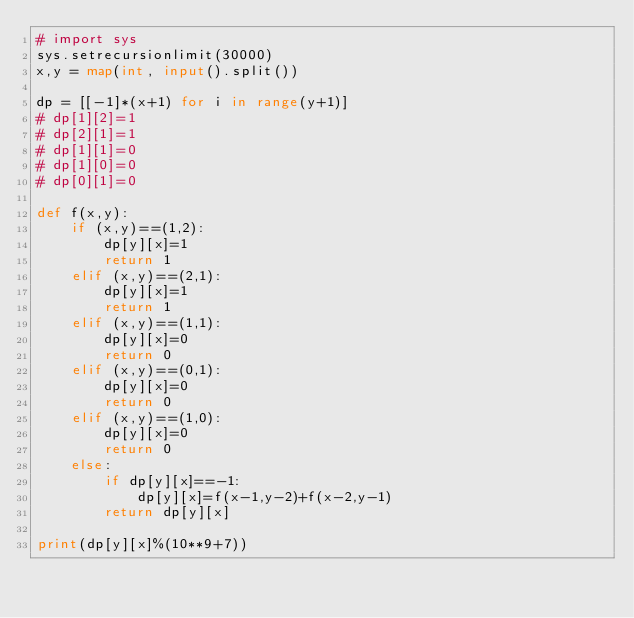Convert code to text. <code><loc_0><loc_0><loc_500><loc_500><_Python_># import sys
sys.setrecursionlimit(30000)
x,y = map(int, input().split())

dp = [[-1]*(x+1) for i in range(y+1)]
# dp[1][2]=1
# dp[2][1]=1
# dp[1][1]=0
# dp[1][0]=0
# dp[0][1]=0

def f(x,y):
    if (x,y)==(1,2):
        dp[y][x]=1
        return 1
    elif (x,y)==(2,1):
        dp[y][x]=1
        return 1
    elif (x,y)==(1,1):
        dp[y][x]=0
        return 0
    elif (x,y)==(0,1):
        dp[y][x]=0
        return 0
    elif (x,y)==(1,0):
        dp[y][x]=0
        return 0
    else:
        if dp[y][x]==-1:
            dp[y][x]=f(x-1,y-2)+f(x-2,y-1)
        return dp[y][x]

print(dp[y][x]%(10**9+7))
</code> 